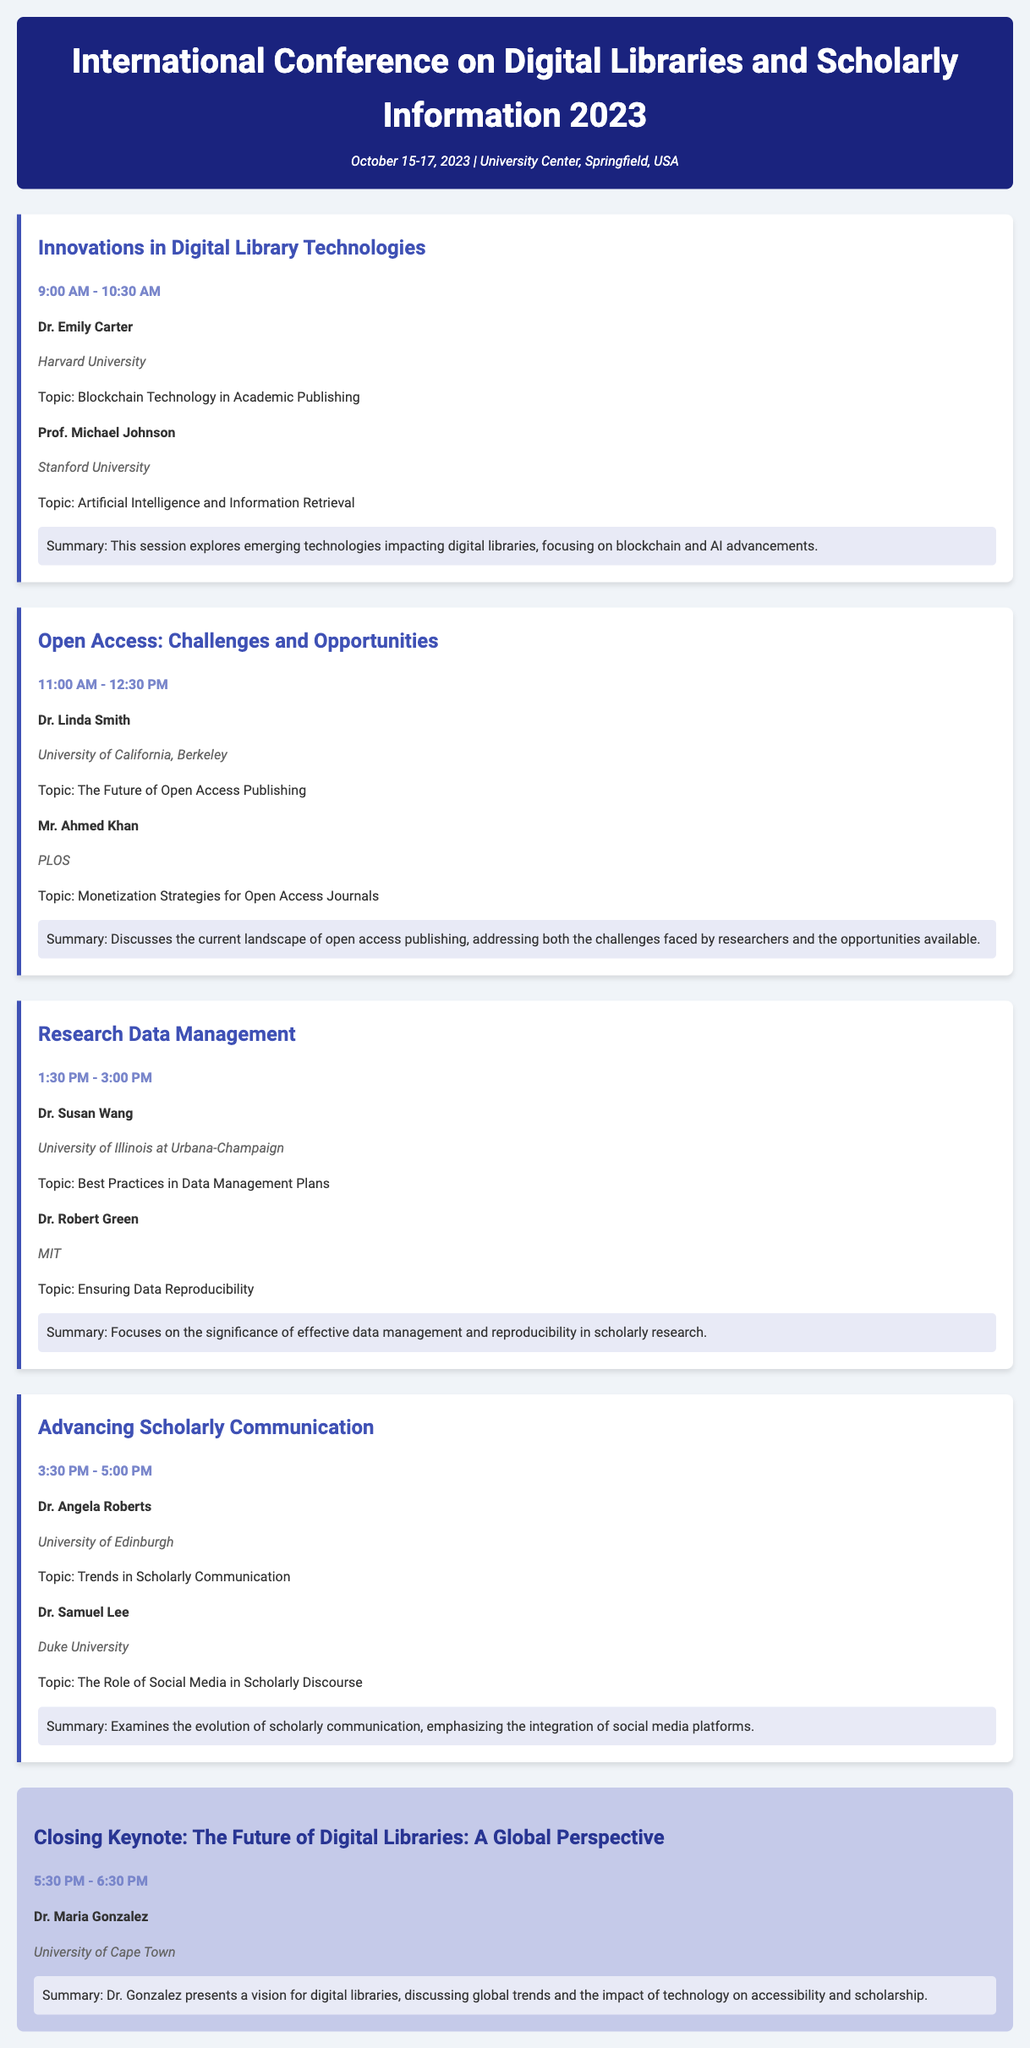What is the name of the conference? The conference is titled "International Conference on Digital Libraries and Scholarly Information 2023."
Answer: International Conference on Digital Libraries and Scholarly Information 2023 Who presented the closing keynote? The closing keynote was presented by Dr. Maria Gonzalez.
Answer: Dr. Maria Gonzalez What is the time for the session on "Research Data Management"? The session "Research Data Management" is from 1:30 PM to 3:00 PM.
Answer: 1:30 PM - 3:00 PM Which university is Dr. Linda Smith affiliated with? Dr. Linda Smith is affiliated with the University of California, Berkeley.
Answer: University of California, Berkeley What topic did Prof. Michael Johnson discuss? Prof. Michael Johnson discussed "Artificial Intelligence and Information Retrieval."
Answer: Artificial Intelligence and Information Retrieval What is the focus of the session titled "Innovations in Digital Library Technologies"? The session focuses on emerging technologies impacting digital libraries.
Answer: Emerging technologies impacting digital libraries How many speakers are there in the session on "Open Access: Challenges and Opportunities"? There are two speakers in that session.
Answer: Two speakers What is the main theme of the closing keynote session? The main theme is "The Future of Digital Libraries: A Global Perspective."
Answer: The Future of Digital Libraries: A Global Perspective What is the name of the session that discusses social media in scholarly discourse? The session is titled "Advancing Scholarly Communication."
Answer: Advancing Scholarly Communication 